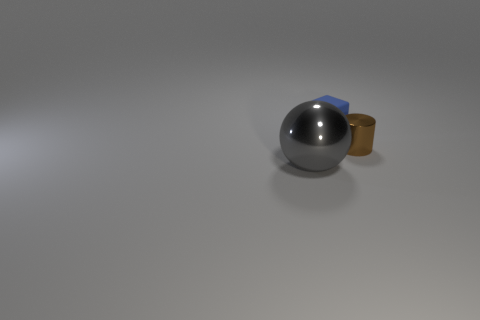Is there any other thing that is the same size as the ball?
Provide a succinct answer. No. There is a thing that is in front of the tiny object right of the thing that is behind the small cylinder; what is its size?
Give a very brief answer. Large. What size is the brown cylinder that is made of the same material as the large ball?
Your response must be concise. Small. Does the gray metal sphere have the same size as the metal object right of the rubber cube?
Your answer should be very brief. No. The object in front of the cylinder has what shape?
Offer a terse response. Sphere. There is a shiny thing that is in front of the tiny thing that is in front of the blue block; is there a gray thing that is on the left side of it?
Provide a short and direct response. No. Is there any other thing that has the same material as the blue cube?
Offer a very short reply. No. What number of balls are tiny blue things or large things?
Offer a very short reply. 1. Do the shiny object right of the large metal ball and the rubber object that is behind the small brown metallic cylinder have the same size?
Keep it short and to the point. Yes. The object left of the small thing that is to the left of the small brown metallic cylinder is made of what material?
Your answer should be very brief. Metal. 